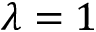Convert formula to latex. <formula><loc_0><loc_0><loc_500><loc_500>\lambda = 1</formula> 